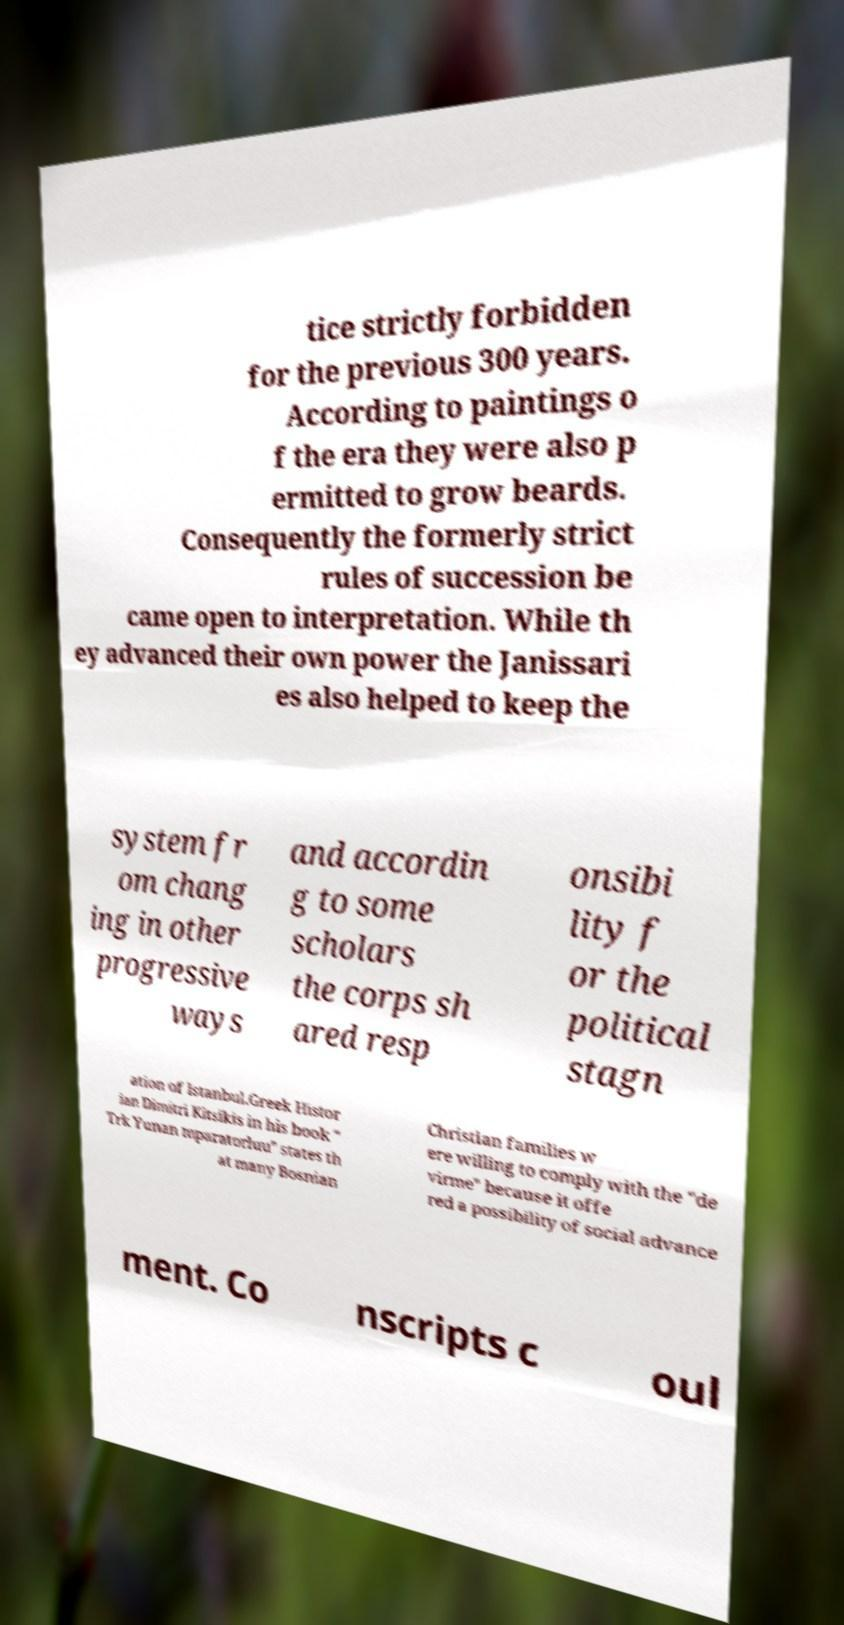Can you accurately transcribe the text from the provided image for me? tice strictly forbidden for the previous 300 years. According to paintings o f the era they were also p ermitted to grow beards. Consequently the formerly strict rules of succession be came open to interpretation. While th ey advanced their own power the Janissari es also helped to keep the system fr om chang ing in other progressive ways and accordin g to some scholars the corps sh ared resp onsibi lity f or the political stagn ation of Istanbul.Greek Histor ian Dimitri Kitsikis in his book " Trk Yunan mparatorluu" states th at many Bosnian Christian families w ere willing to comply with the "de virme" because it offe red a possibility of social advance ment. Co nscripts c oul 